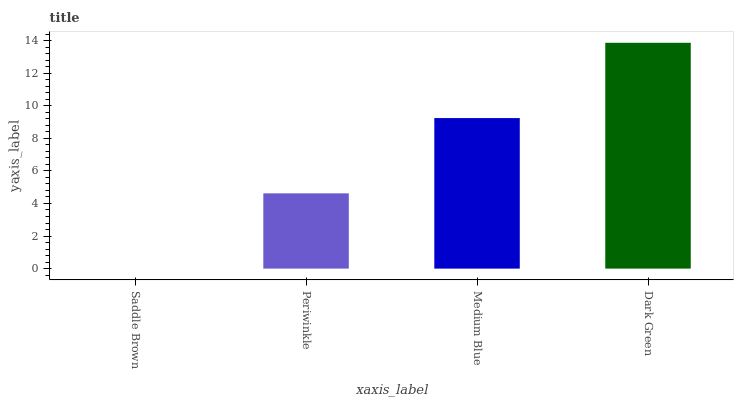Is Saddle Brown the minimum?
Answer yes or no. Yes. Is Dark Green the maximum?
Answer yes or no. Yes. Is Periwinkle the minimum?
Answer yes or no. No. Is Periwinkle the maximum?
Answer yes or no. No. Is Periwinkle greater than Saddle Brown?
Answer yes or no. Yes. Is Saddle Brown less than Periwinkle?
Answer yes or no. Yes. Is Saddle Brown greater than Periwinkle?
Answer yes or no. No. Is Periwinkle less than Saddle Brown?
Answer yes or no. No. Is Medium Blue the high median?
Answer yes or no. Yes. Is Periwinkle the low median?
Answer yes or no. Yes. Is Saddle Brown the high median?
Answer yes or no. No. Is Medium Blue the low median?
Answer yes or no. No. 